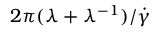Convert formula to latex. <formula><loc_0><loc_0><loc_500><loc_500>2 \pi ( \lambda + \lambda ^ { - 1 } ) / \dot { \gamma }</formula> 